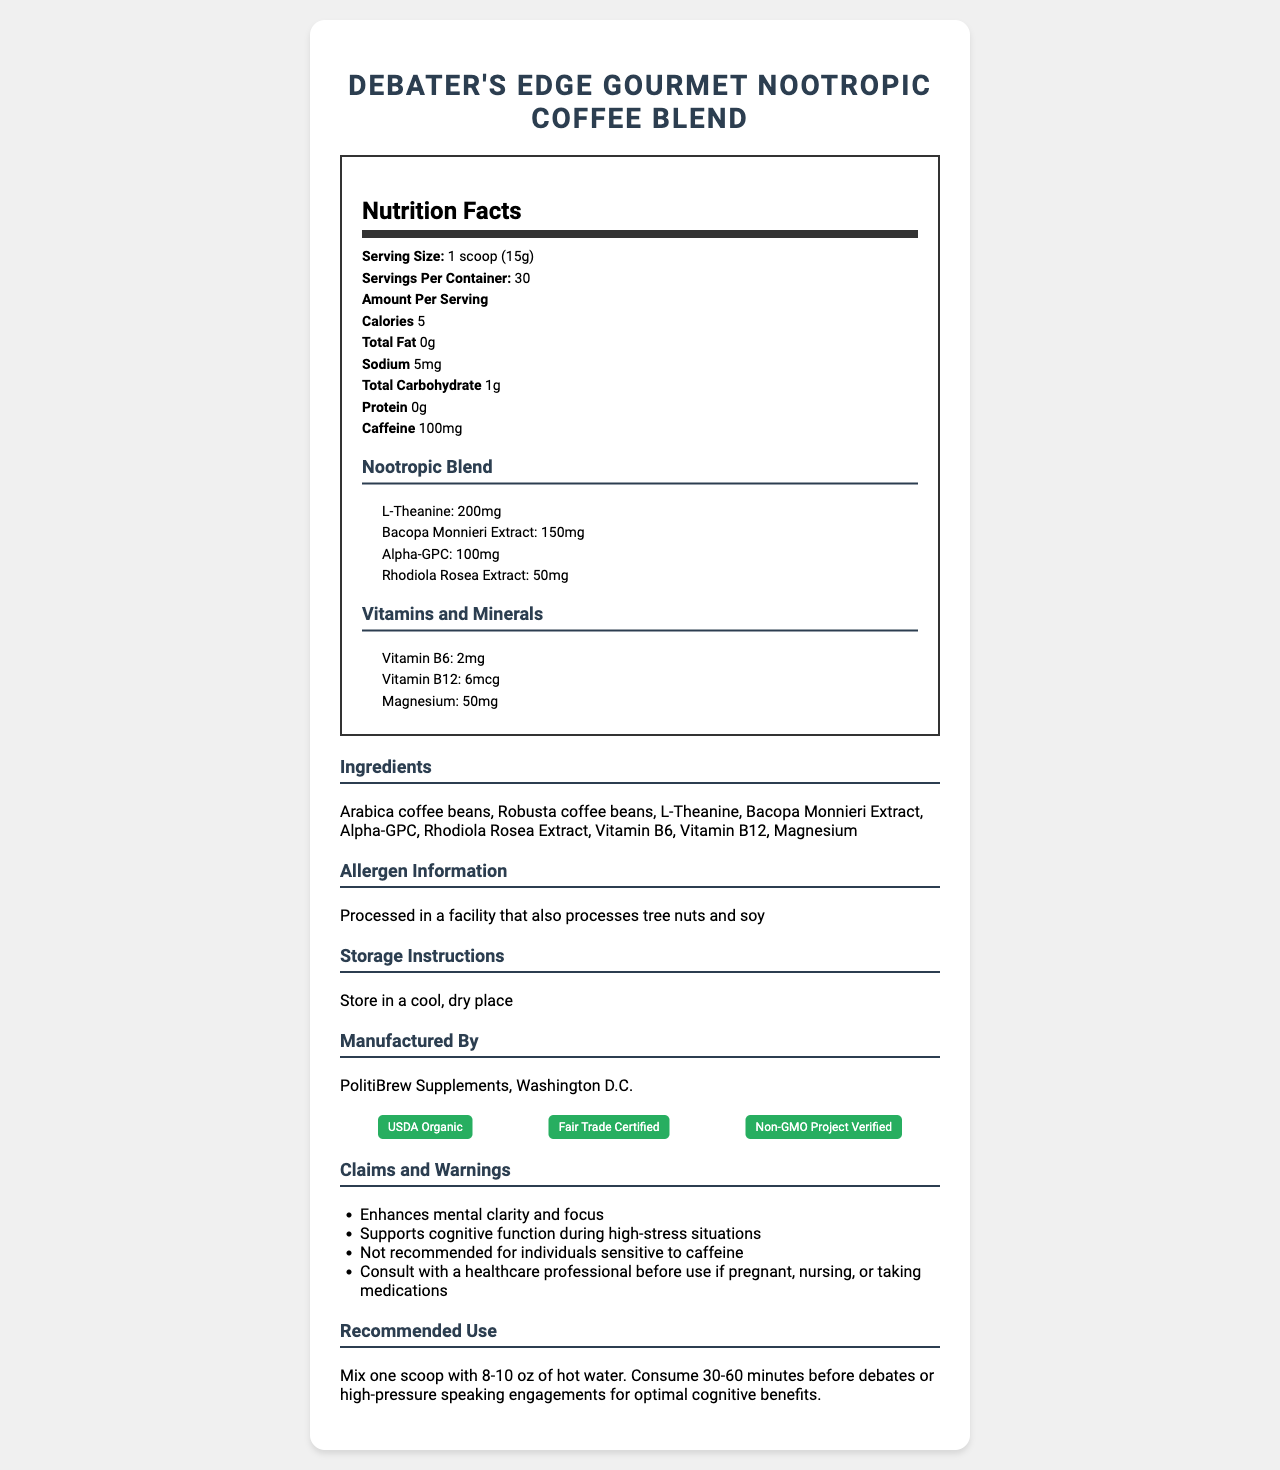what is the serving size? The serving size is indicated directly under the “Nutrition Facts” label as "1 scoop (15g)".
Answer: 1 scoop (15g) how many servings are there per container? The document states "Servings Per Container: 30" under the Nutrition Facts section.
Answer: 30 how much caffeine is in each serving? The caffeine content per serving is listed as "Caffeine: 100mg" in the Nutrition Facts.
Answer: 100mg what are the main ingredients in the coffee blend? The main ingredients are listed in the Ingredients section of the document.
Answer: Arabica coffee beans, Robusta coffee beans, L-Theanine, Bacopa Monnieri Extract, Alpha-GPC, Rhodiola Rosea Extract, Vitamin B6, Vitamin B12, Magnesium what vitamin provides 2mg per serving? The Vitamins and Minerals section lists Vitamin B6 as providing 2mg per serving.
Answer: Vitamin B6 are there any warnings related to caffeine? The Claims and Warnings section includes "Not recommended for individuals sensitive to caffeine."
Answer: Yes which component of the nootropic blend is present in the highest amount? Under the Nootropic Blend section, L-Theanine is listed as "200mg", which is the highest compared to the other components.
Answer: L-Theanine what is the total carbohydrate content per serving? The total carbohydrate content is listed as "Total Carbohydrate: 1g" per serving.
Answer: 1g who manufactures Debater's Edge Gourmet Nootropic Coffee Blend? The Manufactured By section states that it is manufactured by "PolitiBrew Supplements, Washington D.C."
Answer: PolitiBrew Supplements, Washington D.C. what is the recommended use for this product? The Recommended Use section provides this information.
Answer: Mix one scoop with 8-10 oz of hot water. Consume 30-60 minutes before debates or high-pressure speaking engagements for optimal cognitive benefits. how should the product be stored? The Storage Instructions section states "Store in a cool, dry place."
Answer: In a cool, dry place how much sodium does one serving contain? A. 0mg B. 5mg C. 50mg D. 100mg The sodium content is listed as "Sodium: 5mg" per serving.
Answer: B which of the following is NOT one of the vitamins present in the coffee blend? I. Vitamin B6 II. Vitamin B12 III. Vitamin C The Vitamins and Minerals section only lists Vitamin B6 and Vitamin B12; Vitamin C is not mentioned.
Answer: III. Vitamin C is the coffee blend gluten-free? The document does not provide any information regarding gluten content.
Answer: Not enough information summarize the main purpose of Debater's Edge Gourmet Nootropic Coffee Blend. The document emphasizes the cognitive benefits provided by the nootropic blend and the detailed supplement information.
Answer: The main purpose of Debater's Edge Gourmet Nootropic Coffee Blend is to enhance mental clarity and focus, supporting cognitive function during high-pressure situations like debates, through a combination of coffee and nootropic ingredients. what is the calorie content per serving? The specific calorie amount per serving is listed as "Calories: 5" in the Nutrition Facts.
Answer: 5 calories 